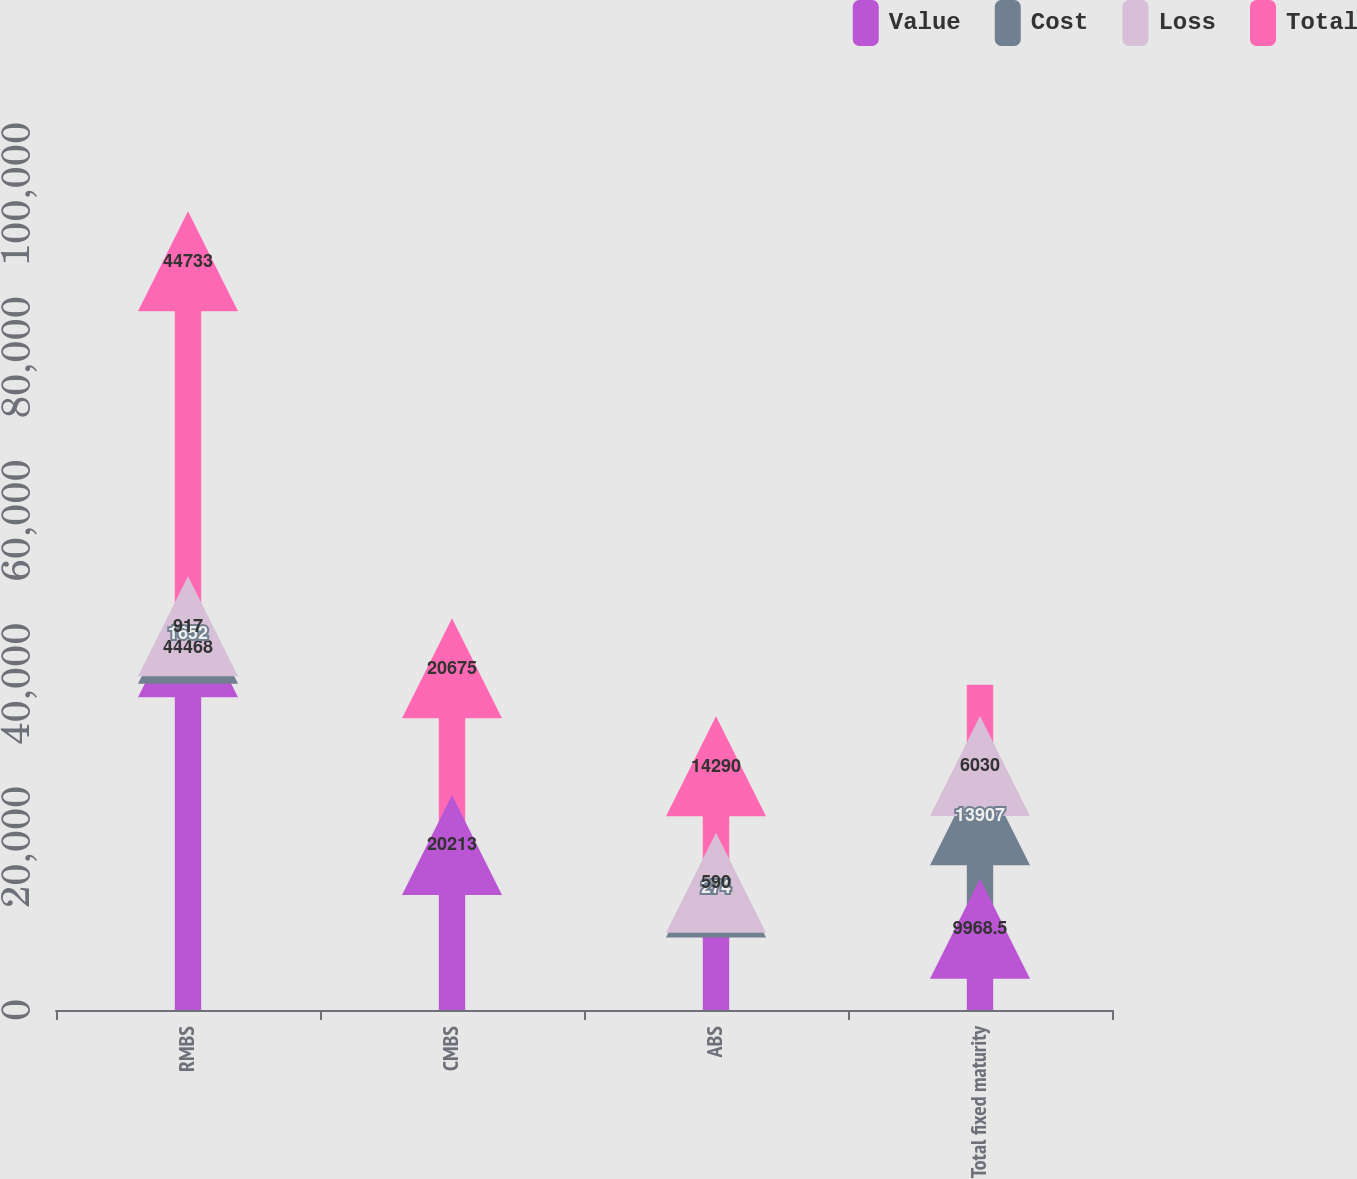Convert chart to OTSL. <chart><loc_0><loc_0><loc_500><loc_500><stacked_bar_chart><ecel><fcel>RMBS<fcel>CMBS<fcel>ABS<fcel>Total fixed maturity<nl><fcel>Value<fcel>44468<fcel>20213<fcel>14725<fcel>9968.5<nl><fcel>Cost<fcel>1652<fcel>740<fcel>274<fcel>13907<nl><fcel>Loss<fcel>917<fcel>266<fcel>590<fcel>6030<nl><fcel>Total<fcel>44733<fcel>20675<fcel>14290<fcel>9968.5<nl></chart> 